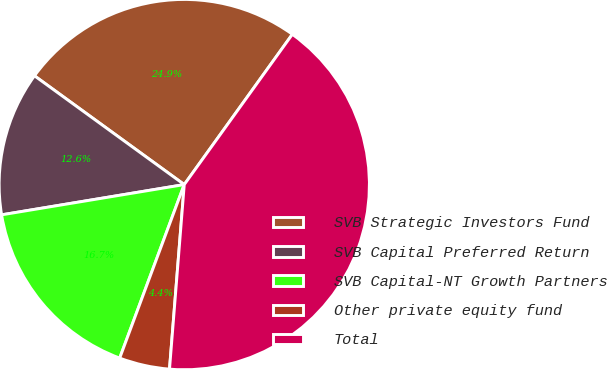Convert chart. <chart><loc_0><loc_0><loc_500><loc_500><pie_chart><fcel>SVB Strategic Investors Fund<fcel>SVB Capital Preferred Return<fcel>SVB Capital-NT Growth Partners<fcel>Other private equity fund<fcel>Total<nl><fcel>24.93%<fcel>12.61%<fcel>16.72%<fcel>4.4%<fcel>41.35%<nl></chart> 